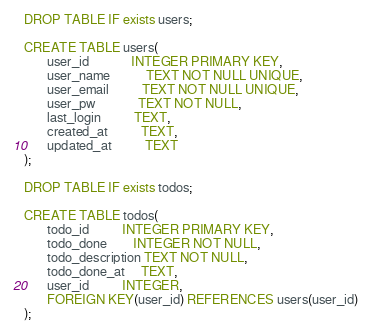Convert code to text. <code><loc_0><loc_0><loc_500><loc_500><_SQL_>DROP TABLE IF exists users;

CREATE TABLE users(
       user_id             INTEGER PRIMARY KEY,
       user_name           TEXT NOT NULL UNIQUE,
       user_email          TEXT NOT NULL UNIQUE,
       user_pw             TEXT NOT NULL,
       last_login          TEXT,
       created_at          TEXT,
       updated_at          TEXT
);

DROP TABLE IF exists todos;

CREATE TABLE todos(
       todo_id          INTEGER PRIMARY KEY,
       todo_done        INTEGER NOT NULL,
       todo_description TEXT NOT NULL,
       todo_done_at     TEXT,
       user_id          INTEGER,
       FOREIGN KEY(user_id) REFERENCES users(user_id)
);
</code> 